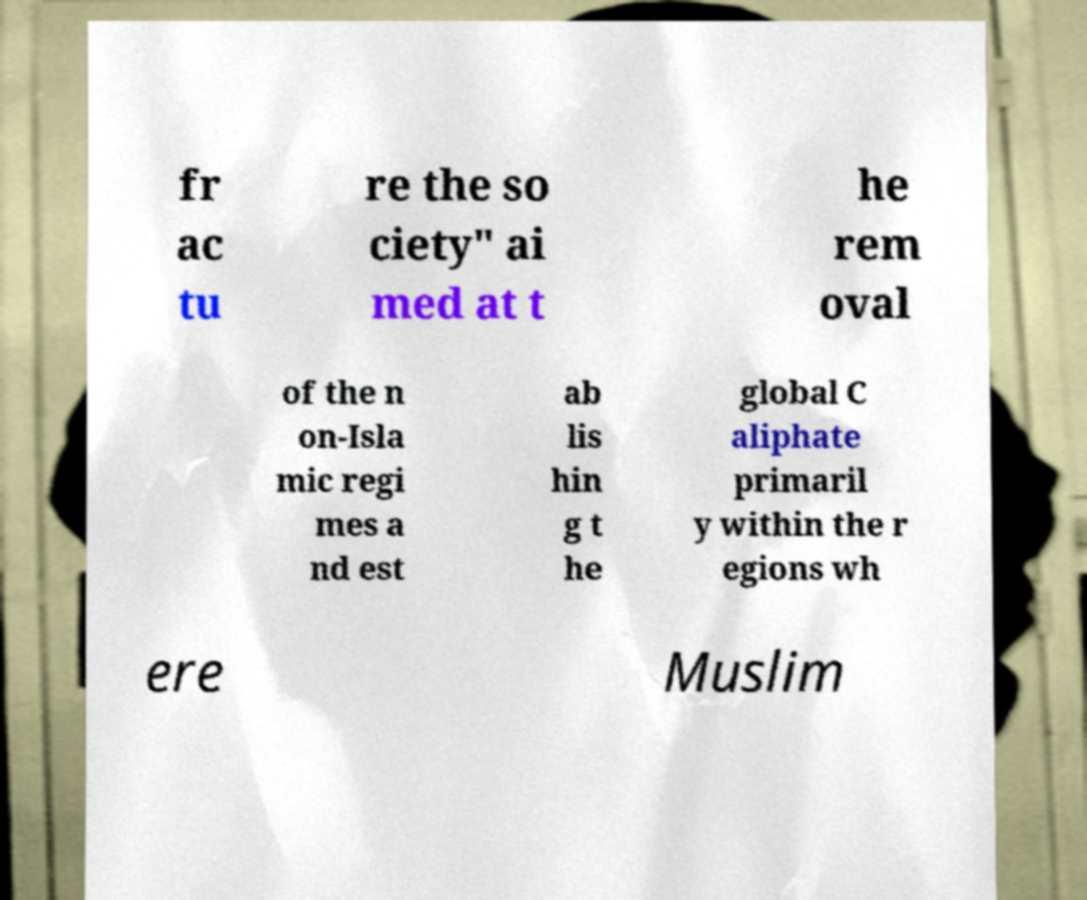Please identify and transcribe the text found in this image. fr ac tu re the so ciety" ai med at t he rem oval of the n on-Isla mic regi mes a nd est ab lis hin g t he global C aliphate primaril y within the r egions wh ere Muslim 